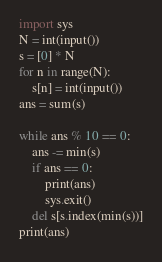Convert code to text. <code><loc_0><loc_0><loc_500><loc_500><_Python_>import sys
N = int(input())
s = [0] * N
for n in range(N):
    s[n] = int(input())
ans = sum(s)

while ans % 10 == 0:
    ans -= min(s)
    if ans == 0:
        print(ans)
        sys.exit()
    del s[s.index(min(s))]
print(ans)</code> 